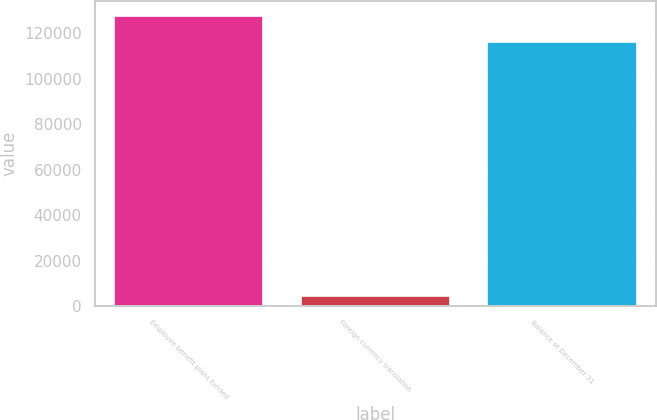Convert chart. <chart><loc_0><loc_0><loc_500><loc_500><bar_chart><fcel>Employee benefit plans funded<fcel>Foreign currency translation<fcel>Balance at December 31<nl><fcel>127810<fcel>4214<fcel>116191<nl></chart> 